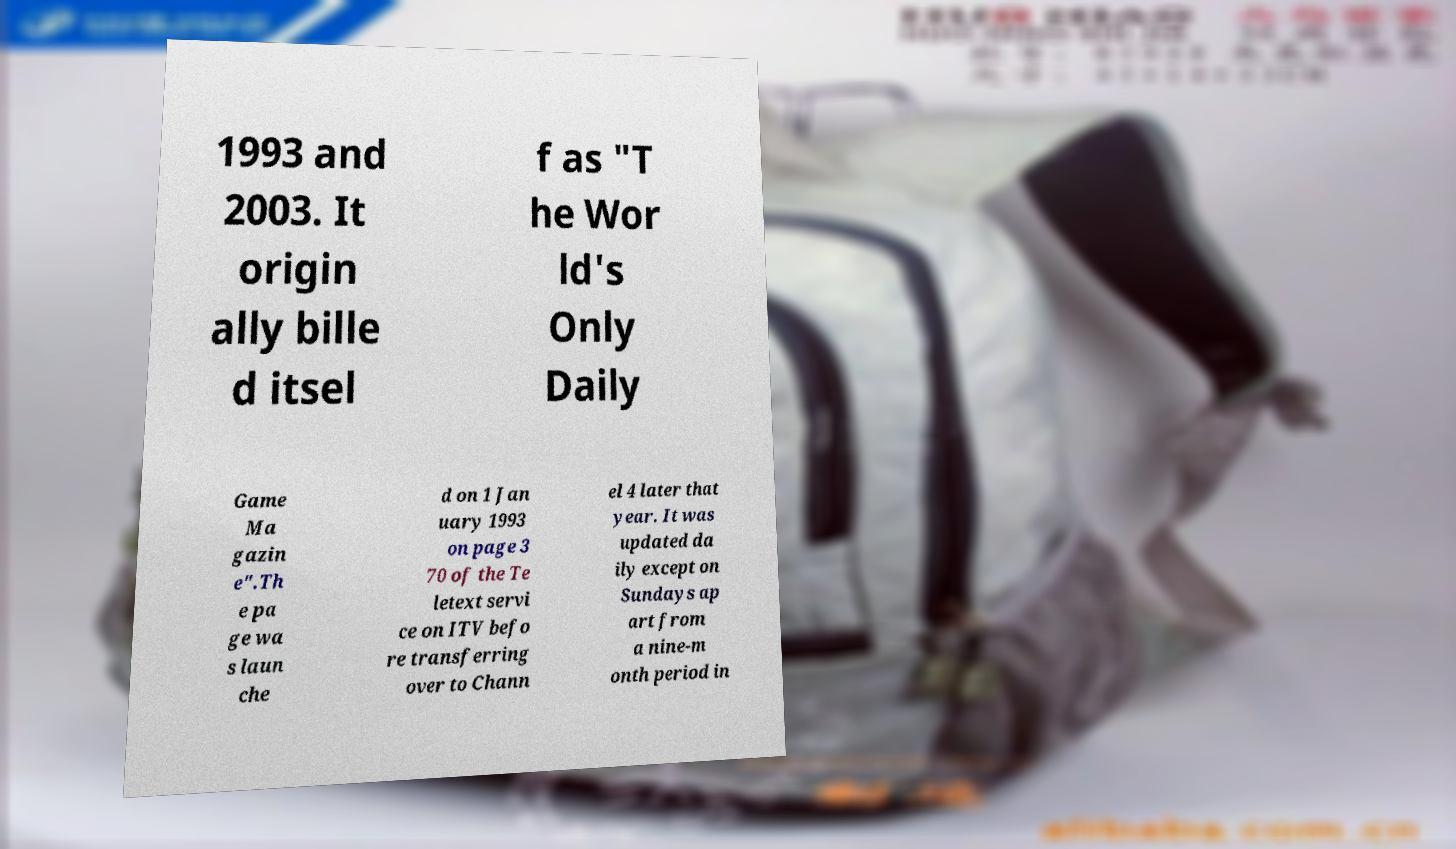Please identify and transcribe the text found in this image. 1993 and 2003. It origin ally bille d itsel f as "T he Wor ld's Only Daily Game Ma gazin e".Th e pa ge wa s laun che d on 1 Jan uary 1993 on page 3 70 of the Te letext servi ce on ITV befo re transferring over to Chann el 4 later that year. It was updated da ily except on Sundays ap art from a nine-m onth period in 